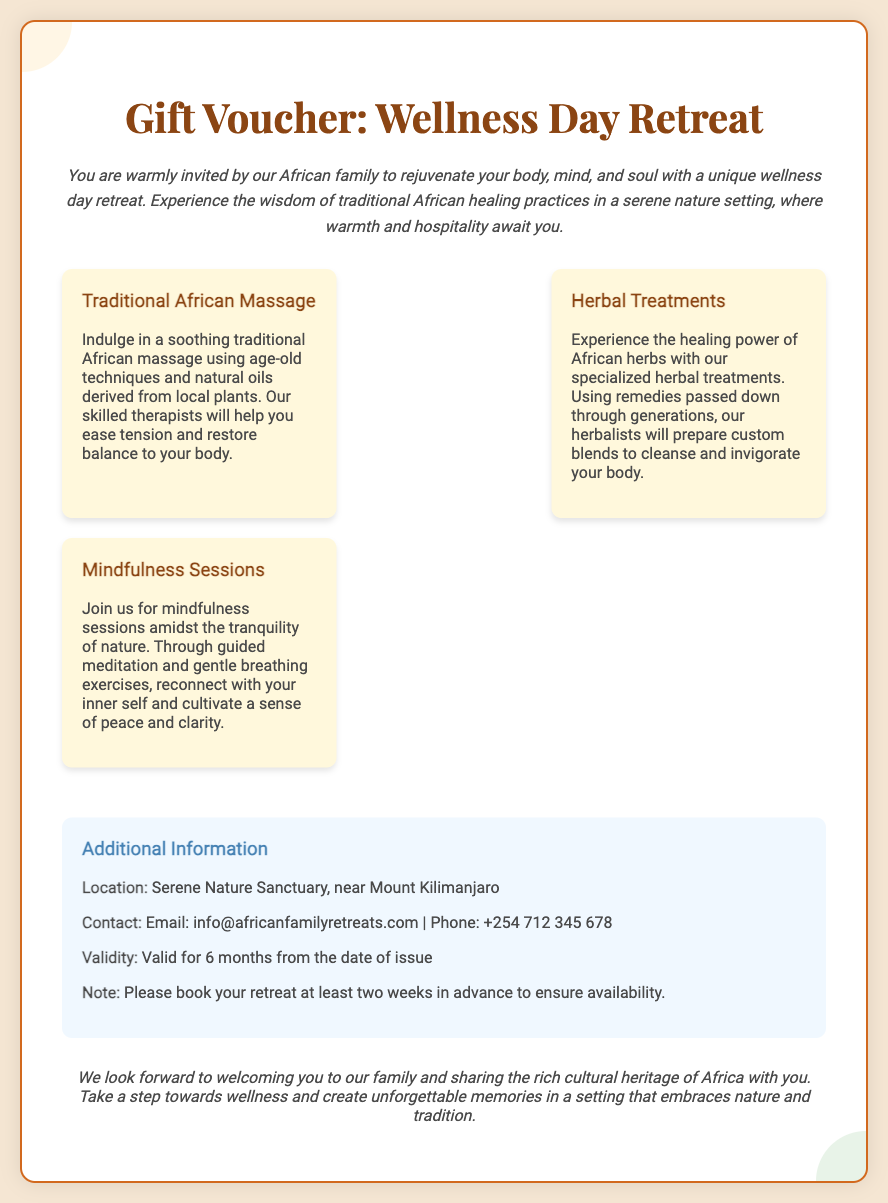What is included in the retreat? The retreat includes Traditional African Massage, Herbal Treatments, and Mindfulness Sessions as listed in the services section.
Answer: Traditional African Massage, Herbal Treatments, Mindfulness Sessions Where is the location of the retreat? The location of the retreat is specified in the additional information section as Serene Nature Sanctuary.
Answer: Serene Nature Sanctuary What is the validity period of the voucher? The validity period is mentioned in the additional information section, indicating how long the voucher can be used.
Answer: 6 months What type of treatments are offered? The document specifies that herbal treatments are part of the services offered during the wellness retreat.
Answer: Herbal Treatments How should I book my retreat? The additional information section notes that booking should be done at least two weeks in advance, indicating the time frame required for scheduling.
Answer: At least two weeks in advance What type of massage is featured? The document explicitly states that Traditional African Massage is featured among the services provided.
Answer: Traditional African Massage What will participants experience during mindfulness sessions? The document outlines that participants will engage in guided meditation and gentle breathing exercises during mindfulness sessions.
Answer: Guided meditation and gentle breathing exercises 